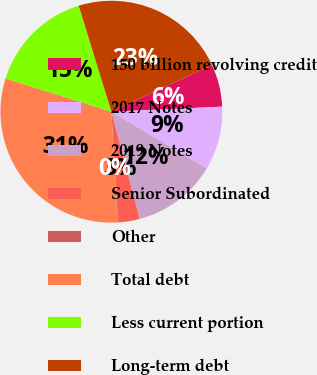Convert chart. <chart><loc_0><loc_0><loc_500><loc_500><pie_chart><fcel>150 billion revolving credit<fcel>2017 Notes<fcel>2019 Notes<fcel>Senior Subordinated<fcel>Other<fcel>Total debt<fcel>Less current portion<fcel>Long-term debt<nl><fcel>6.21%<fcel>9.27%<fcel>12.34%<fcel>3.15%<fcel>0.08%<fcel>30.72%<fcel>15.4%<fcel>22.83%<nl></chart> 